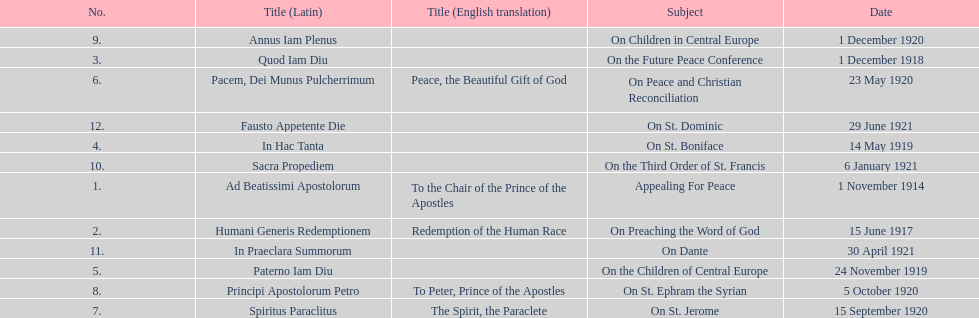What is the subject listed after appealing for peace? On Preaching the Word of God. 